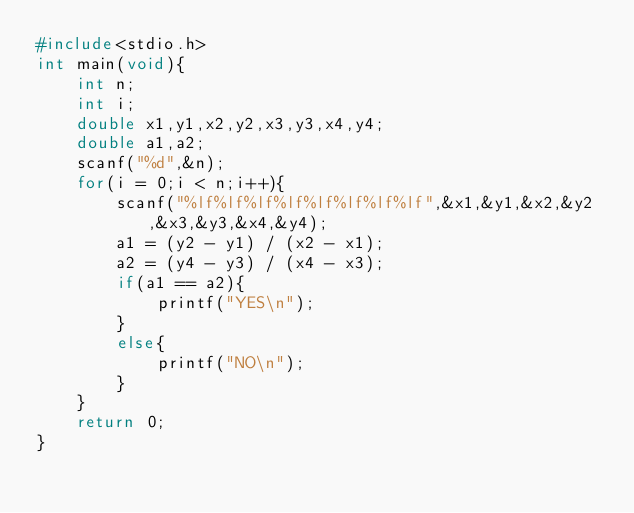Convert code to text. <code><loc_0><loc_0><loc_500><loc_500><_C_>#include<stdio.h>
int main(void){
	int n;
	int i;
	double x1,y1,x2,y2,x3,y3,x4,y4;
	double a1,a2;
	scanf("%d",&n);
	for(i = 0;i < n;i++){
		scanf("%lf%lf%lf%lf%lf%lf%lf%lf",&x1,&y1,&x2,&y2,&x3,&y3,&x4,&y4);
		a1 = (y2 - y1) / (x2 - x1);
		a2 = (y4 - y3) / (x4 - x3);
		if(a1 == a2){
			printf("YES\n");
		}
		else{
			printf("NO\n");
		}
	}
	return 0;
}</code> 